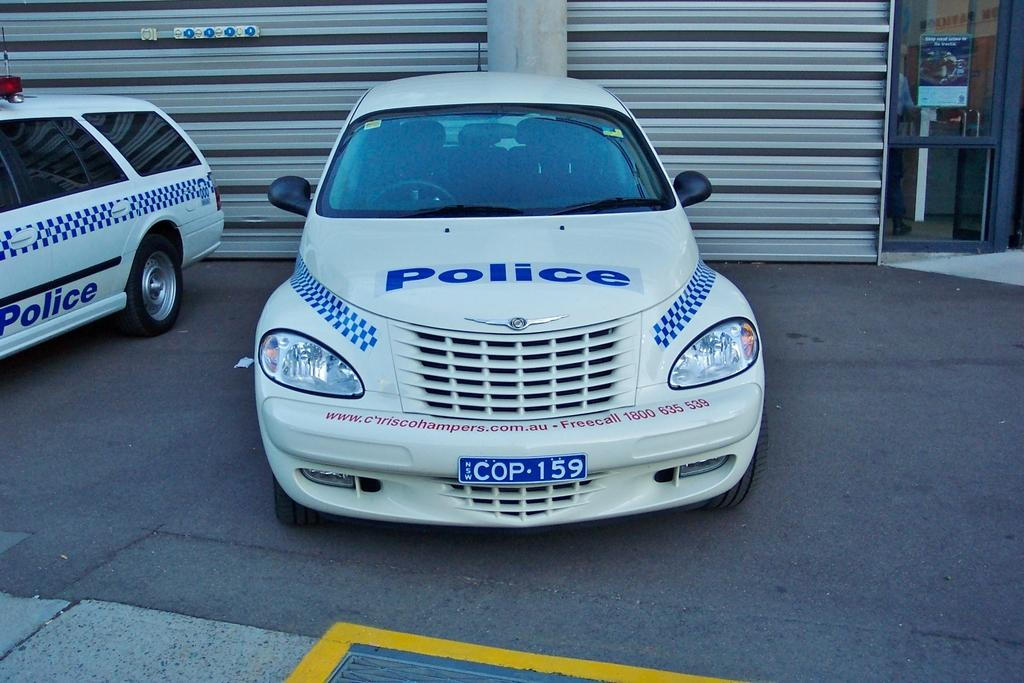Provide a one-sentence caption for the provided image. The vehicle is used in Australia by local police and officers. 